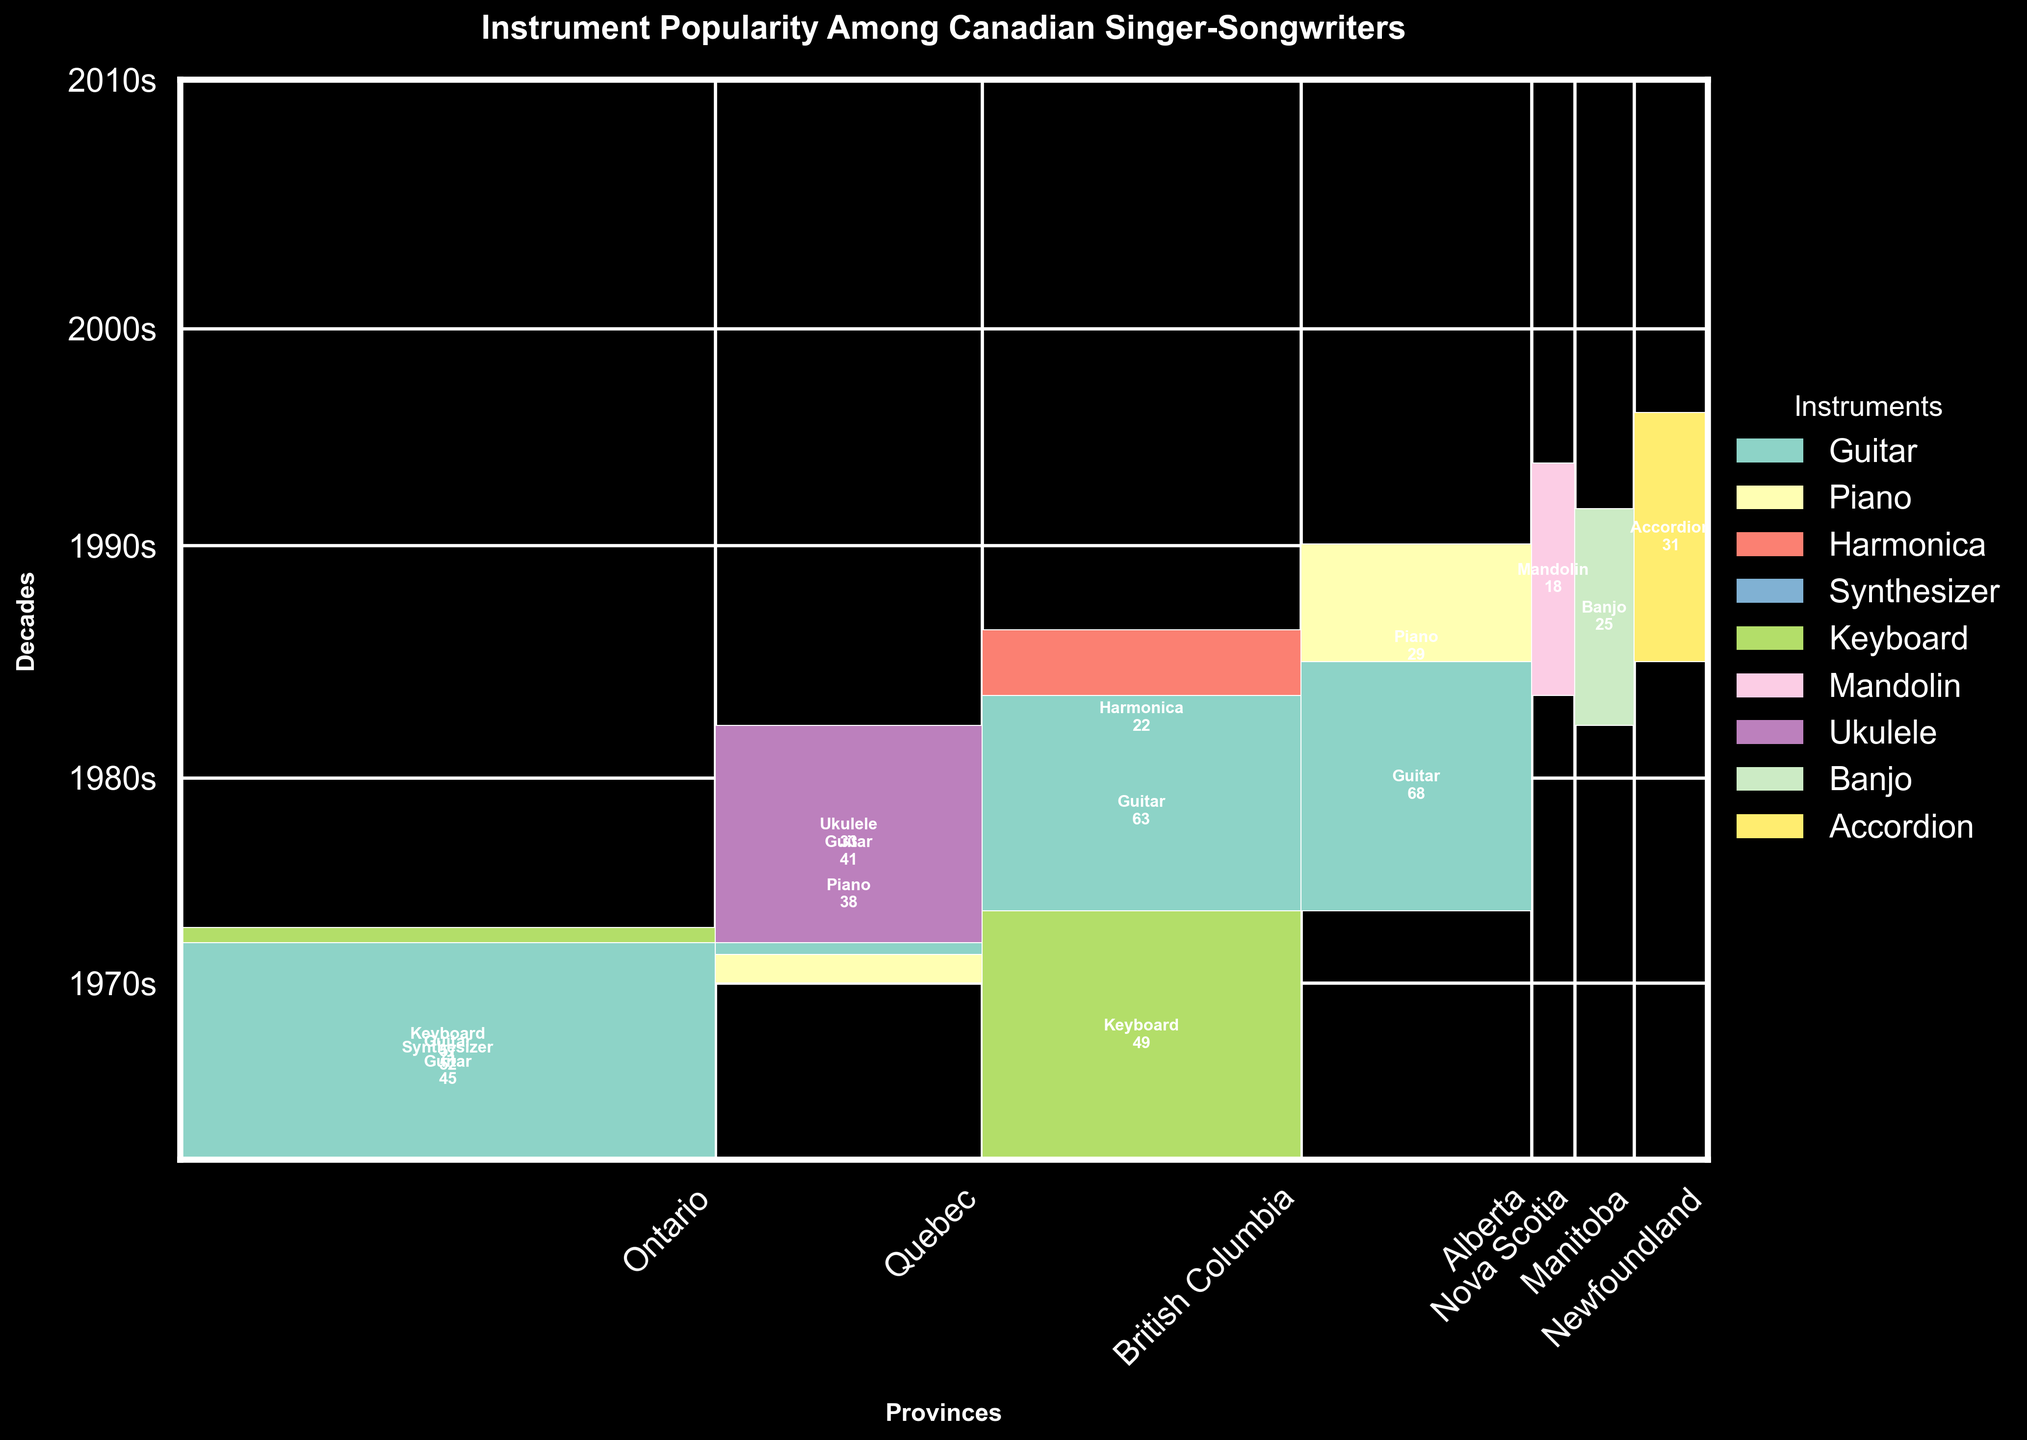What is the title of the figure? The title is typically displayed at the top of the figure, usually in a larger and bold font to differentiate it from other text elements.
Answer: Instrument Popularity Among Canadian Singer-Songwriters Which province has the most diverse instrument usage in the 1980s? Look at the provinces and check which one has the most number of different colored segments in the 1980s.
Answer: Ontario What instrument was most popular in Ontario in the 2000s? Identify the color corresponding to Ontario in the 2000s, and see which instrument has the largest segment in Ontario for that decade.
Answer: Guitar How does the popularity of the Guitar change from the 1970s to the 2010s? Observe the segments representing Guitar in each decade. Compare the segment sizes across decades from the 1970s to the 2010s.
Answer: Increases Which province in the 1990s had the least diversity of instruments? Look for the province in the 1990s with the fewest different colored segments, indicating less variety of instruments.
Answer: Nova Scotia How many provinces had Guitar as the most popular instrument in the 2010s? Count the provinces in the 2010s where the segment labeled Guitar is the largest.
Answer: Two Which instrument becomes popular in Quebec in the 2000s that wasn't prominent before? Identify the new instrument segment appearing in Quebec in the 2000s that is different from previous decades.
Answer: Ukulele What is the most visible change in instrument popularity for British Columbia across the decades? Track the segments for British Columbia across each decade, noting any new or disappearing instruments or changes in segment sizes.
Answer: Increase in Keyboard in the 2010s 